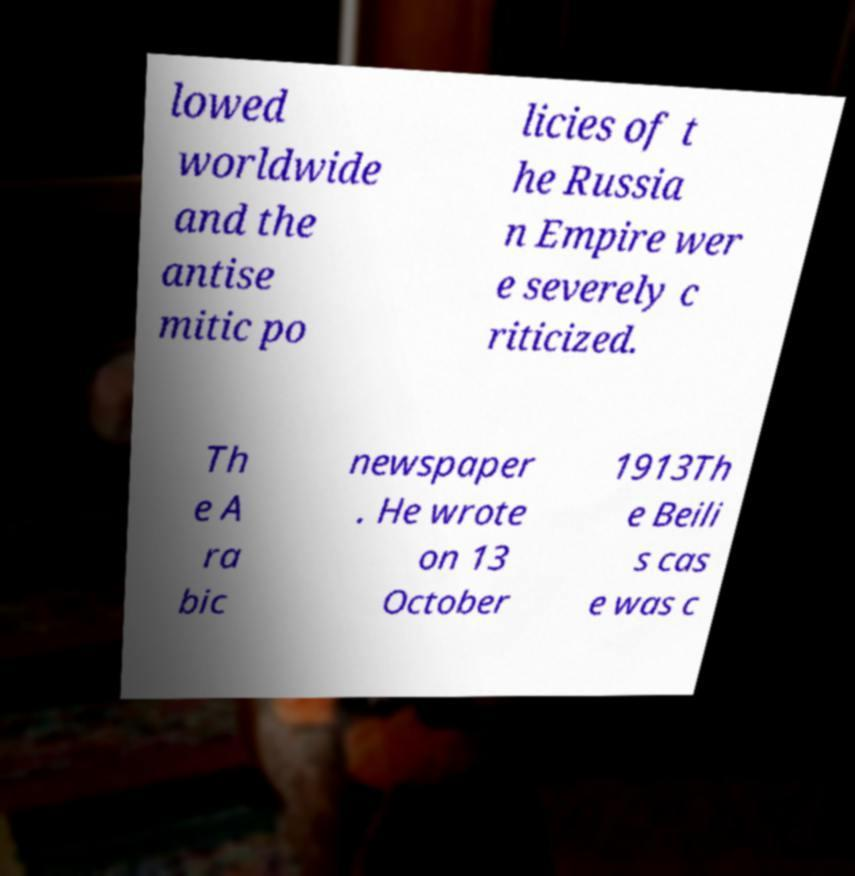For documentation purposes, I need the text within this image transcribed. Could you provide that? lowed worldwide and the antise mitic po licies of t he Russia n Empire wer e severely c riticized. Th e A ra bic newspaper . He wrote on 13 October 1913Th e Beili s cas e was c 